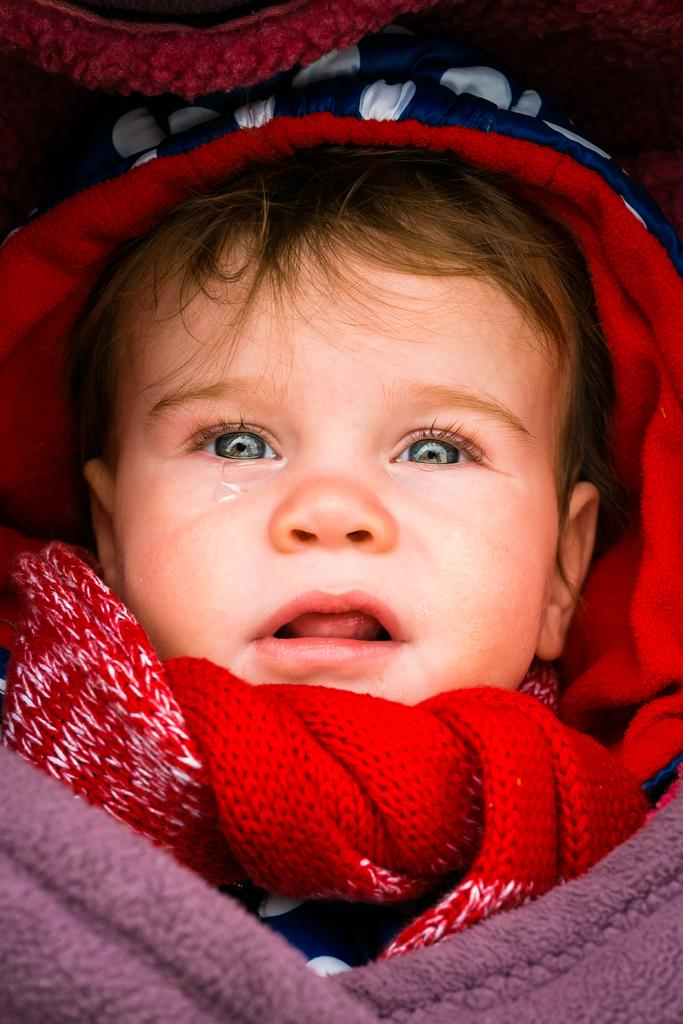What is the main subject of the image? The main subject of the image is a baby. What is the baby wearing on their head? The baby is wearing a red color cap. What type of clothing is the baby wearing on their upper body? The baby is wearing a violet color sweater. What ideas does the baby have about the aftermath of the recent storm? There is no indication in the image that the baby has any ideas about the aftermath of a storm, as the image only shows the baby wearing a red cap and a violet sweater. Can you tell me how many dogs are present in the image? There are no dogs present in the image; it only features a baby wearing a red cap and a violet sweater. 